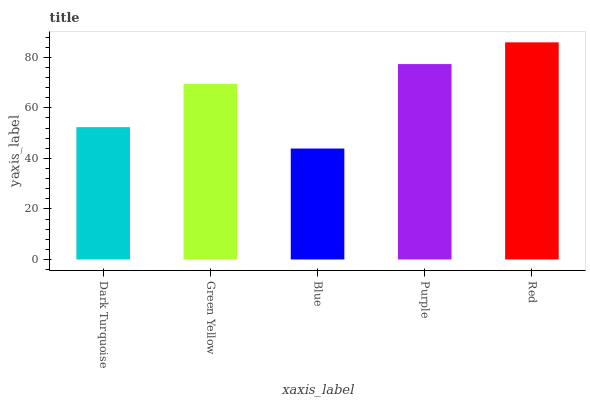Is Blue the minimum?
Answer yes or no. Yes. Is Red the maximum?
Answer yes or no. Yes. Is Green Yellow the minimum?
Answer yes or no. No. Is Green Yellow the maximum?
Answer yes or no. No. Is Green Yellow greater than Dark Turquoise?
Answer yes or no. Yes. Is Dark Turquoise less than Green Yellow?
Answer yes or no. Yes. Is Dark Turquoise greater than Green Yellow?
Answer yes or no. No. Is Green Yellow less than Dark Turquoise?
Answer yes or no. No. Is Green Yellow the high median?
Answer yes or no. Yes. Is Green Yellow the low median?
Answer yes or no. Yes. Is Blue the high median?
Answer yes or no. No. Is Blue the low median?
Answer yes or no. No. 